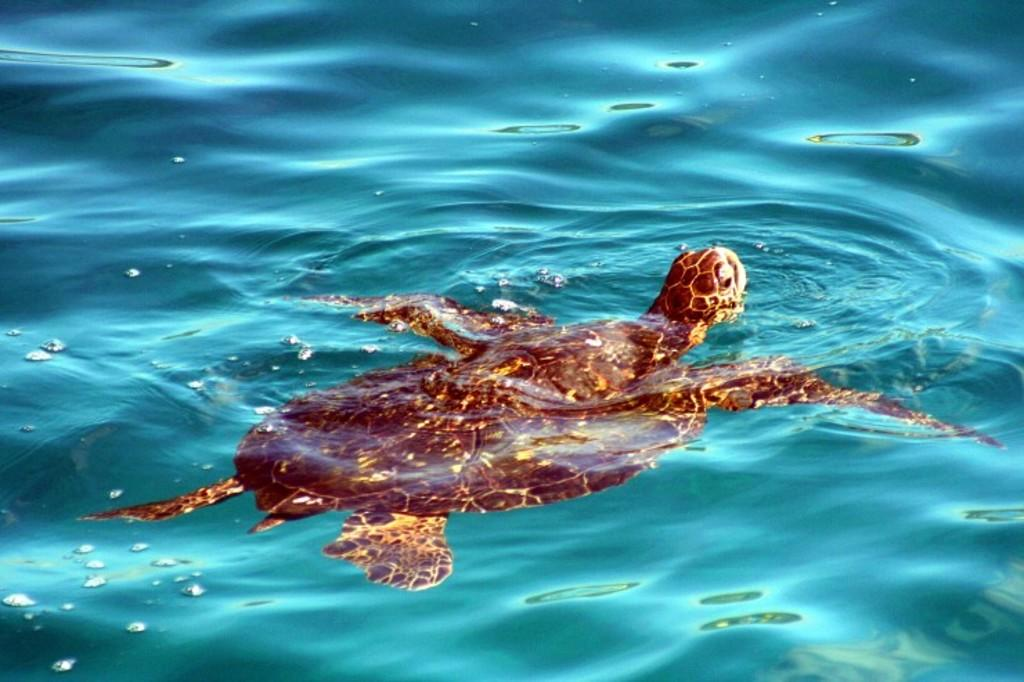What animal is present in the image? There is a tortoise in the image. What is the tortoise doing in the image? The tortoise is floating in the water. What type of caption is written on the tortoise's shell in the image? There is no caption written on the tortoise's shell in the image. How does the wrist of the tortoise look like in the image? Tortoises do not have wrists, as they are reptiles with a different body structure. 